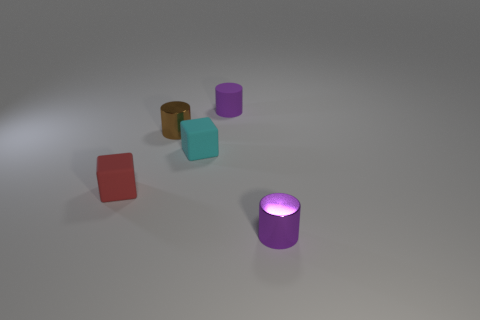What number of purple cylinders have the same size as the purple matte thing?
Keep it short and to the point. 1. How many red cylinders are there?
Ensure brevity in your answer.  0. Are the tiny brown cylinder and the purple cylinder that is behind the small cyan cube made of the same material?
Keep it short and to the point. No. How many red things are either matte cubes or cylinders?
Your answer should be very brief. 1. How many brown metal objects have the same shape as the tiny purple shiny thing?
Keep it short and to the point. 1. Is the number of tiny purple objects on the right side of the tiny cyan thing greater than the number of brown cylinders that are behind the small matte cylinder?
Provide a succinct answer. Yes. Do the tiny rubber cylinder and the small rubber thing that is in front of the cyan object have the same color?
Offer a terse response. No. What material is the red object that is the same size as the brown shiny cylinder?
Offer a very short reply. Rubber. How many things are either cyan rubber objects or purple cylinders that are on the right side of the purple rubber cylinder?
Your answer should be very brief. 2. Do the red matte cube and the matte object that is behind the small cyan cube have the same size?
Your answer should be very brief. Yes. 